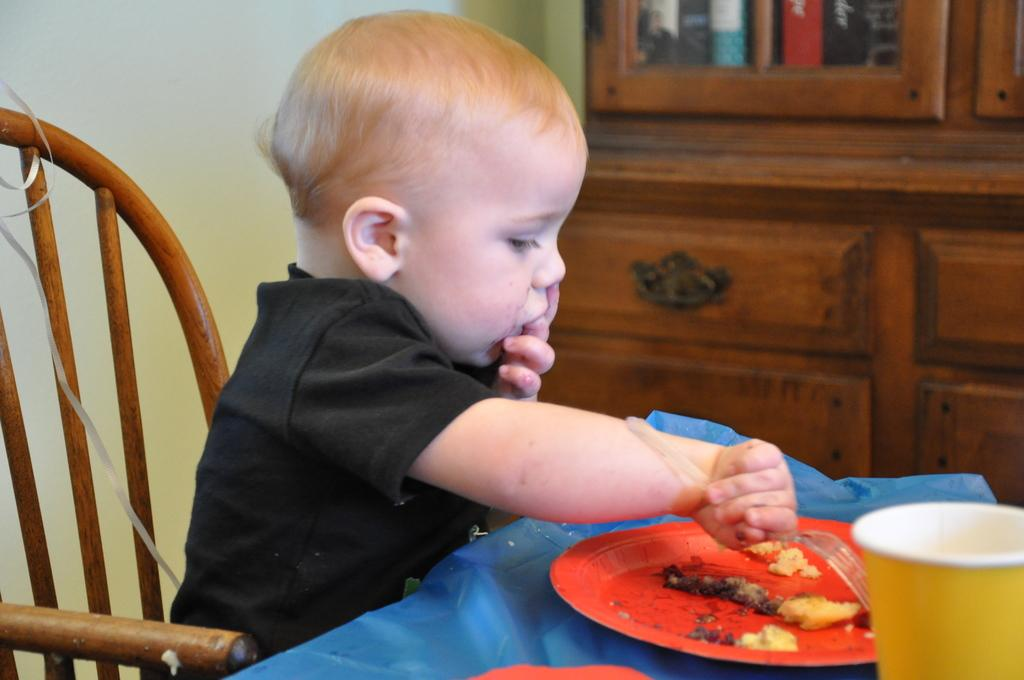What is the kid wearing in the image? The kid is wearing a black t-shirt. What is the kid doing in the image? The kid is sitting on a chair. What is the kid holding in the image? The kid is holding a fork. What can be seen on the table in the image? There is a plate with food and a cup on the table. What is located near the table in the image? There is a cupboard filled with books. What type of flower is growing on the chair in the image? There is no flower growing on the chair in the image; the kid is sitting on it. 